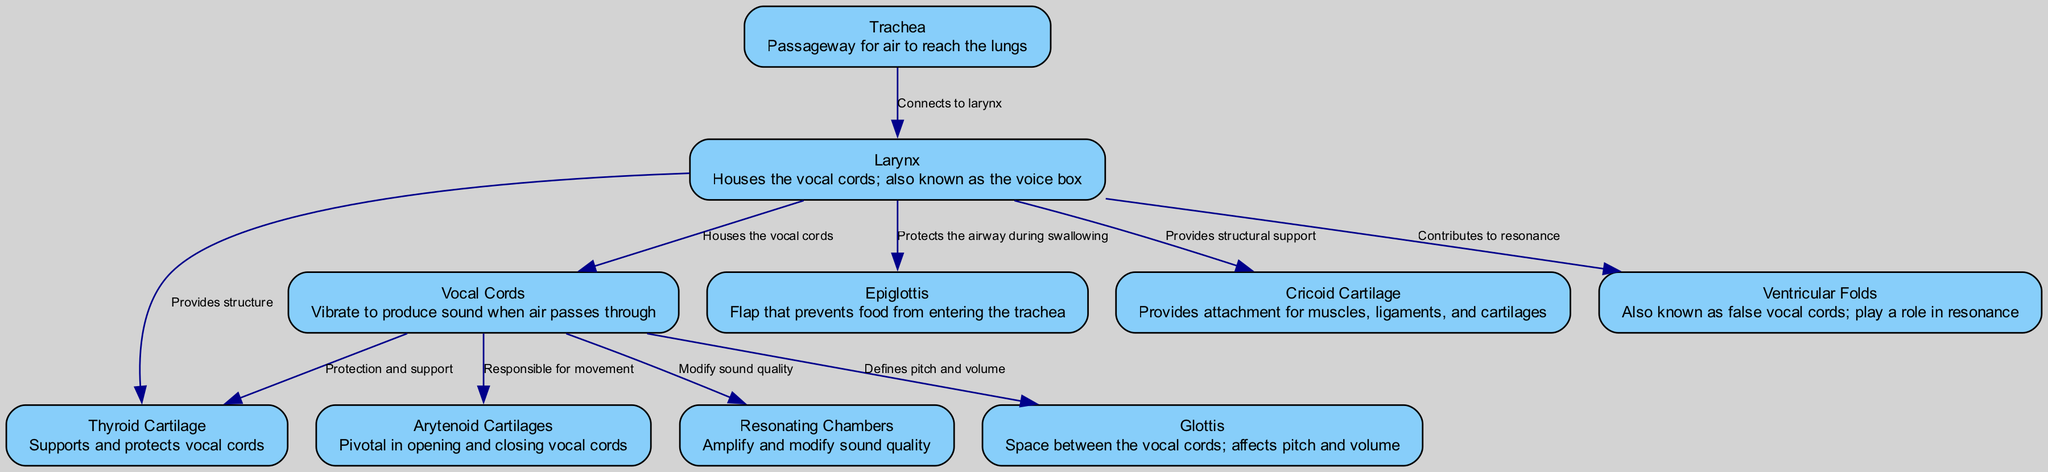What are the vocal cords responsible for? The vocal cords vibrate to produce sound when air passes through them. This description is directly provided in the diagram as the function of the vocal cords.
Answer: Vibrate to produce sound How many nodes are there in the diagram? The diagram contains a total of 10 labeled nodes, each representing a part of the vocal anatomy. By counting the entries under "Nodes" in the data, we confirm this.
Answer: 10 What structure houses the vocal cords? The larynx is identified in the diagram as the structure that houses the vocal cords, making it a focal point in the visual representation.
Answer: Larynx What connects the trachea to the larynx? The diagram shows a direct edge labeled "connects to larynx" linking the trachea to the larynx. This indicates a physical connection between these two structures.
Answer: Larynx Which part prevents food from entering the trachea? The epiglottis is specifically described in the diagram as the flap that prevents food from entering the trachea. This provides a clear description of its protective function.
Answer: Epiglottis How do the arytenoid cartilages affect the vocal cords? The arytenoid cartilages are pivotal in opening and closing the vocal cords, as indicated by their description in the diagram. This relationship illustrates their role in sound modulation.
Answer: Open and close What role do the ventricular folds play? The ventricular folds, also known as false vocal cords, contribute to resonance according to the diagram, indicating their importance in sound production and quality.
Answer: Resonance What part provides structural support to the larynx? Both the thyroid cartilage and cricoid cartilage are indicated in the diagram as providing structural support to the larynx, showing their importance in maintaining its integrity.
Answer: Thyroid cartilage and cricoid cartilage Which component modifies sound quality? The resonating chambers are identified in the diagram as the component that amplifies and modifies sound quality, highlighting their role in the acoustics of vocalization.
Answer: Resonating chambers 